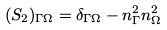<formula> <loc_0><loc_0><loc_500><loc_500>( S _ { 2 } ) _ { \Gamma \Omega } = \delta _ { \Gamma \Omega } - n ^ { 2 } _ { \Gamma } n ^ { 2 } _ { \Omega }</formula> 